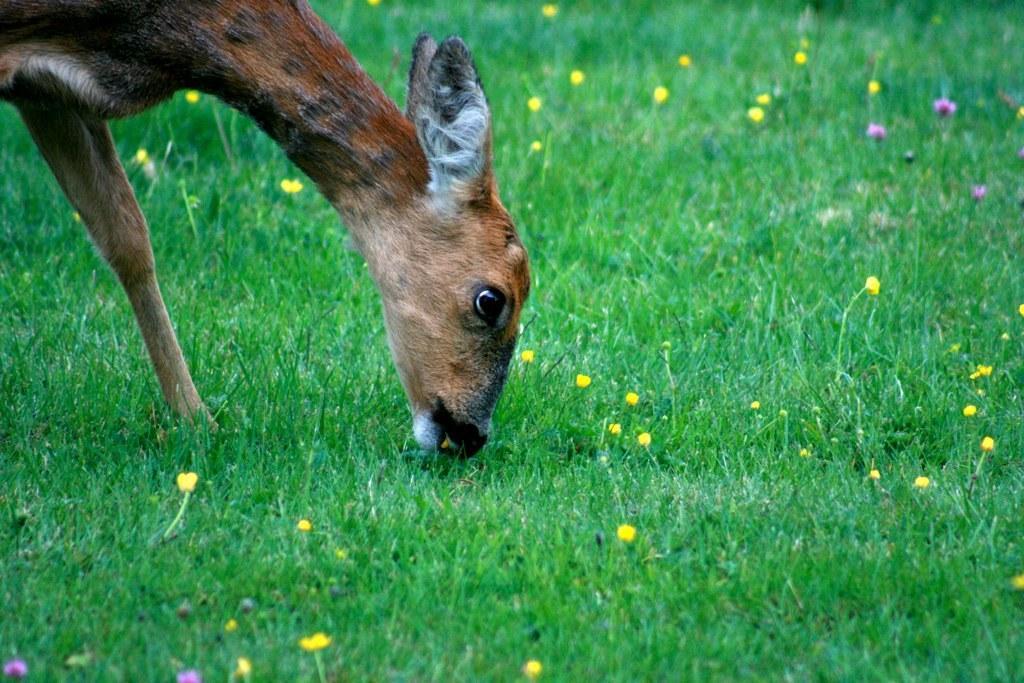Please provide a concise description of this image. In this image there is an animal eating grass in the center. In the front there's grass on the ground and there are flowers on the grass. 